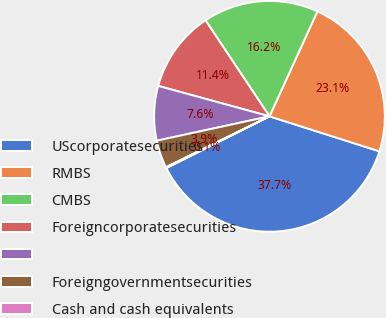Convert chart. <chart><loc_0><loc_0><loc_500><loc_500><pie_chart><fcel>UScorporatesecurities<fcel>RMBS<fcel>CMBS<fcel>Foreigncorporatesecurities<fcel>Unnamed: 4<fcel>Foreigngovernmentsecurities<fcel>Cash and cash equivalents<nl><fcel>37.7%<fcel>23.09%<fcel>16.17%<fcel>11.4%<fcel>7.64%<fcel>3.88%<fcel>0.13%<nl></chart> 